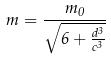<formula> <loc_0><loc_0><loc_500><loc_500>m = \frac { m _ { 0 } } { \sqrt { 6 + \frac { d ^ { 3 } } { c ^ { 3 } } } }</formula> 